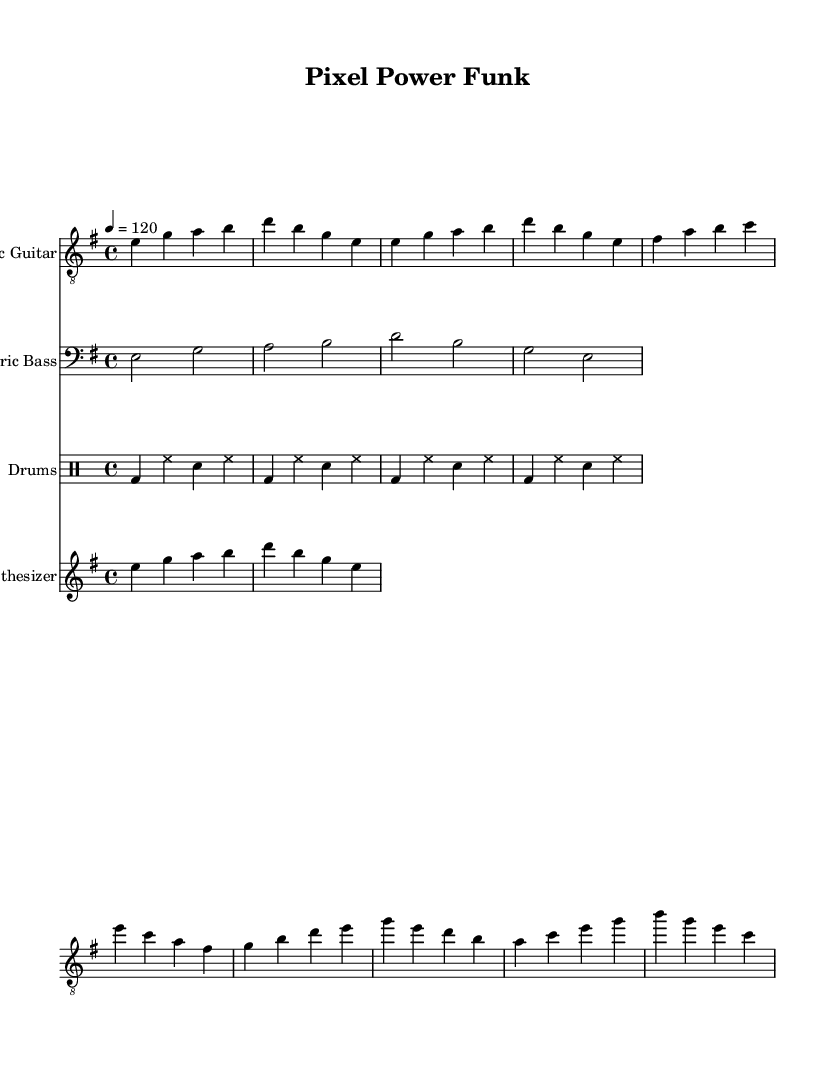What is the key signature of this piece? The key signature is indicated at the beginning of the score, showing two sharps, which corresponds to E minor.
Answer: E minor What is the time signature? The time signature is displayed prominently in the score, indicated as 4/4, meaning four beats per measure.
Answer: 4/4 What is the tempo marking? The tempo is shown in the score with a beat of 120 quarter notes per minute, which is indicated in the tempo setting.
Answer: 120 How many measures does the intro section have? By counting the measures notated in the intro portion of the score, we see there are two measures.
Answer: 2 What instruments are part of the score? The score features four distinct parts, which are listed at the beginning: Electric Guitar, Electric Bass, Drums, and Synthesizer.
Answer: Electric Guitar, Electric Bass, Drums, Synthesizer What is the characteristic rhythmic feel present in funk music shown in the drum part? The drum part exhibits a consistent groove with a strong backbeat primarily focused on the bass drum and snare, common in funk music, marked by the repeated patterns.
Answer: Strong backbeat Which section of the music has the highest pitch? By examining the score, we note that the electric guitar part has higher notes towards the chorus, reaching the highest pitches in that section compared to the bass and synth.
Answer: Chorus 